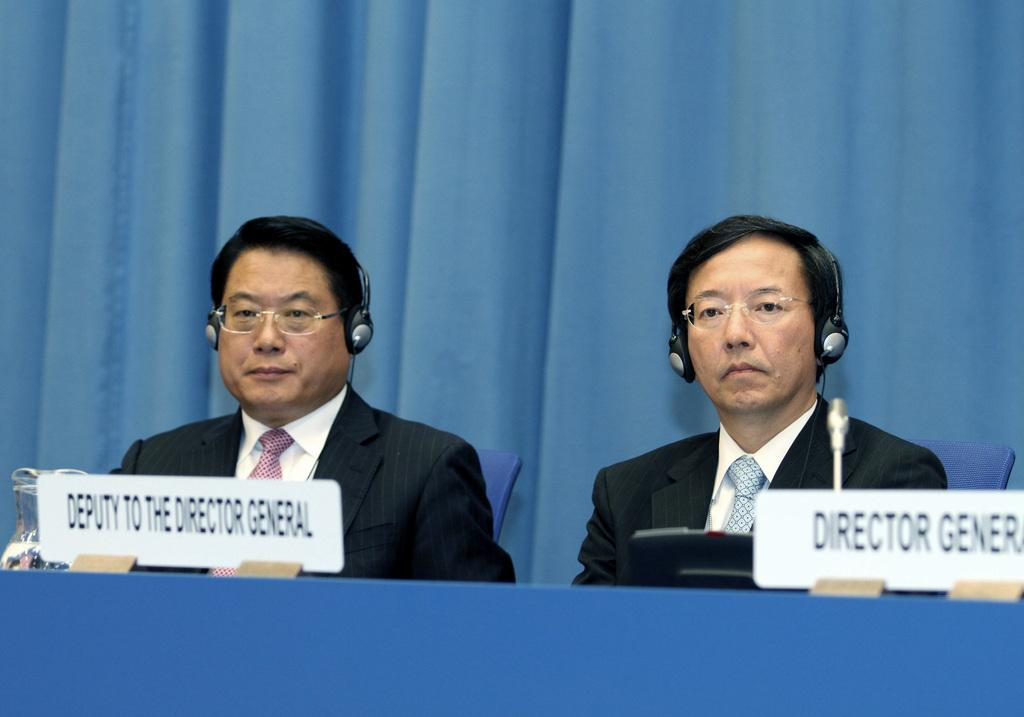<image>
Present a compact description of the photo's key features. two men sitting in front of a blue curtain with one being a director and the other a deputy 